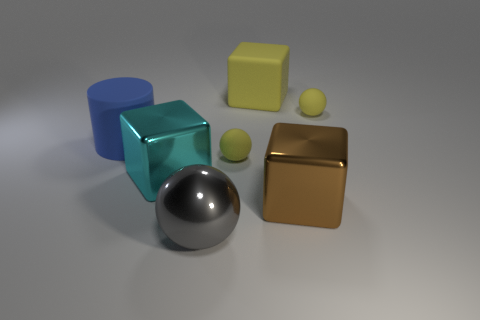Subtract all yellow spheres. How many spheres are left? 1 Add 1 large matte things. How many objects exist? 8 Subtract all yellow cubes. How many cubes are left? 2 Subtract all balls. How many objects are left? 4 Add 3 gray shiny objects. How many gray shiny objects exist? 4 Subtract 0 red spheres. How many objects are left? 7 Subtract 1 cylinders. How many cylinders are left? 0 Subtract all green spheres. Subtract all cyan cubes. How many spheres are left? 3 Subtract all gray cylinders. How many yellow cubes are left? 1 Subtract all large yellow matte cylinders. Subtract all small objects. How many objects are left? 5 